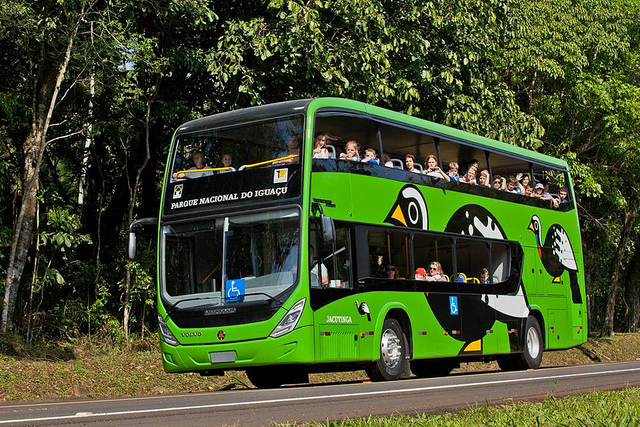<image>What level are the parents sitting on? I don't know what level the parents are sitting on. It might be the first or the bottom level. What level are the parents sitting on? I don't know what level the parents are sitting on. It can be either the first level or the bottom level. 